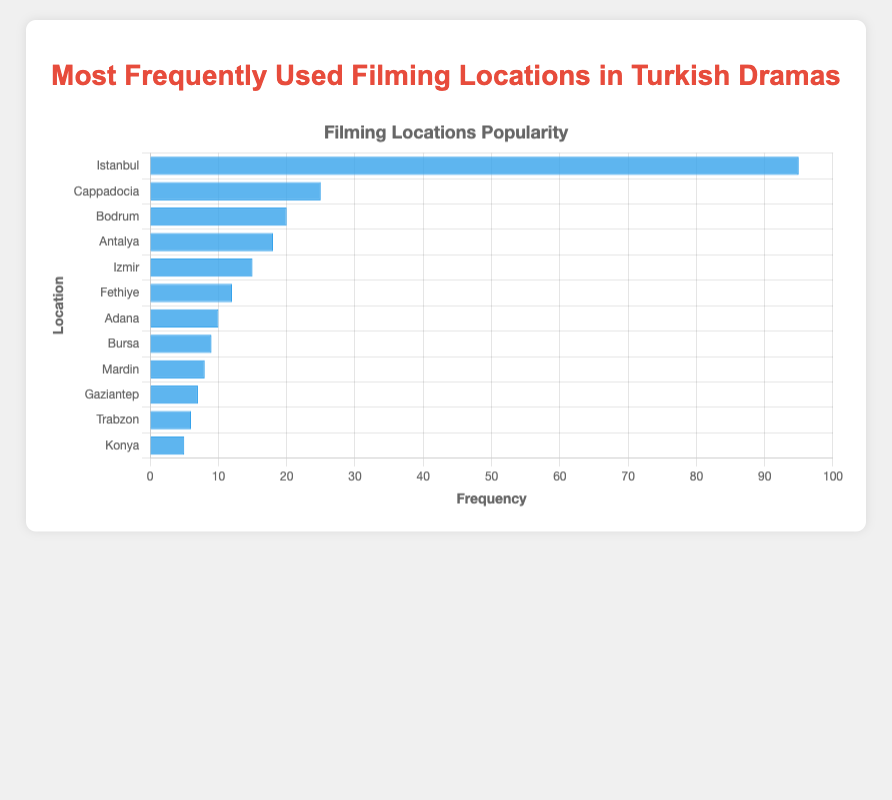What's the most frequently used filming location? The bar for "Istanbul" is the tallest, indicating it's the most frequently used filming location.
Answer: Istanbul Which location is used more frequently, Bodrum or Antalya? Bodrum has a frequency value of 20, while Antalya has a frequency value of 18.
Answer: Bodrum What is the total frequency of all filming locations combined? Sum the frequency values: 95 + 25 + 20 + 18 + 15 + 12 + 10 + 9 + 8 + 7 + 6 + 5 = 230
Answer: 230 How much more frequently is Istanbul used compared to Cappadocia? Subtract the frequency of Cappadocia (25) from Istanbul (95): 95 - 25 = 70
Answer: 70 What is the median frequency value, and which location corresponds to it? First, order the frequency values: 5, 6, 7, 8, 9, 10, 12, 15, 18, 20, 25, 95. The median value is the average of the 6th and 7th values: (10 + 12) / 2 = 11. Location corresponding is Fethiye (as it's closest, but exact median doesn't correspond to single location).
Answer: 11 Which locations have a frequency less than 10? Locations with frequencies 9, 8, 7, 6, and 5 are Bursa, Mardin, Gaziantep, Trabzon, and Konya.
Answer: Bursa, Mardin, Gaziantep, Trabzon, Konya How does the frequency of Izmir compare to that of Fethiye? Izmir has a frequency of 15, while Fethiye has a frequency of 12 which makes Izmir more frequent.
Answer: Izmir is more frequent Which region has the least frequency in the dataset? Konya is the location with the lowest frequency at 5.
Answer: Konya What is the sum of the frequencies for locations that have values greater than 20? Locations with frequencies greater than 20: Istanbul (95) and Cappadocia (25). Sum: 95 + 25 = 120
Answer: 120 